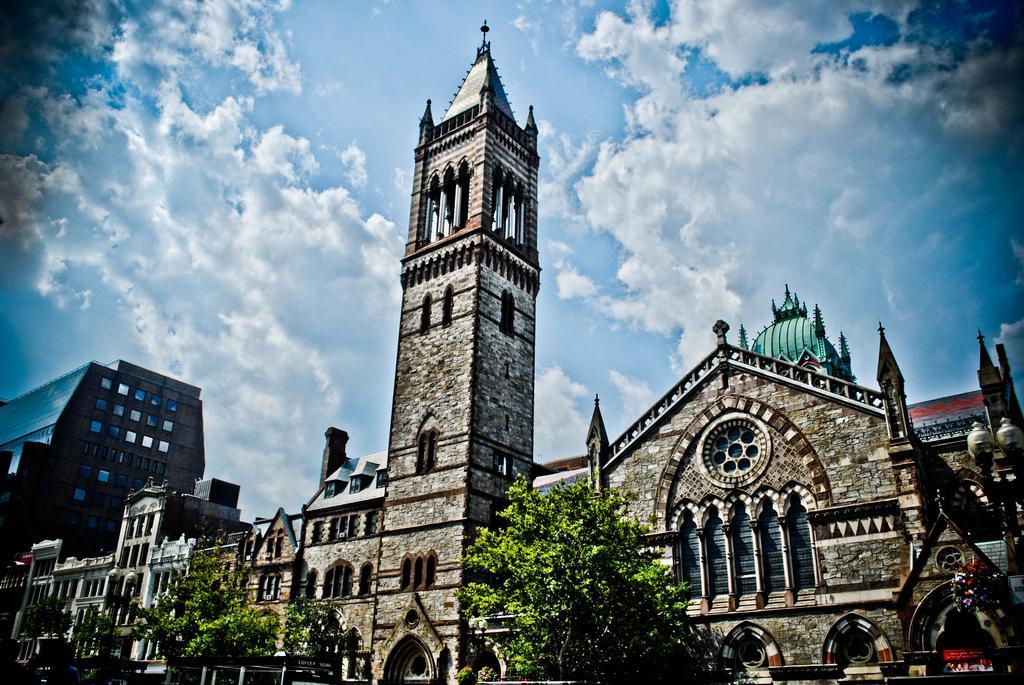Can you describe this image briefly? In this picture, we see a tower and buildings. At the bottom of the picture, we see trees and benches. At the top of the picture, we see the sky and the clouds. This picture might be clicked outside the city. 